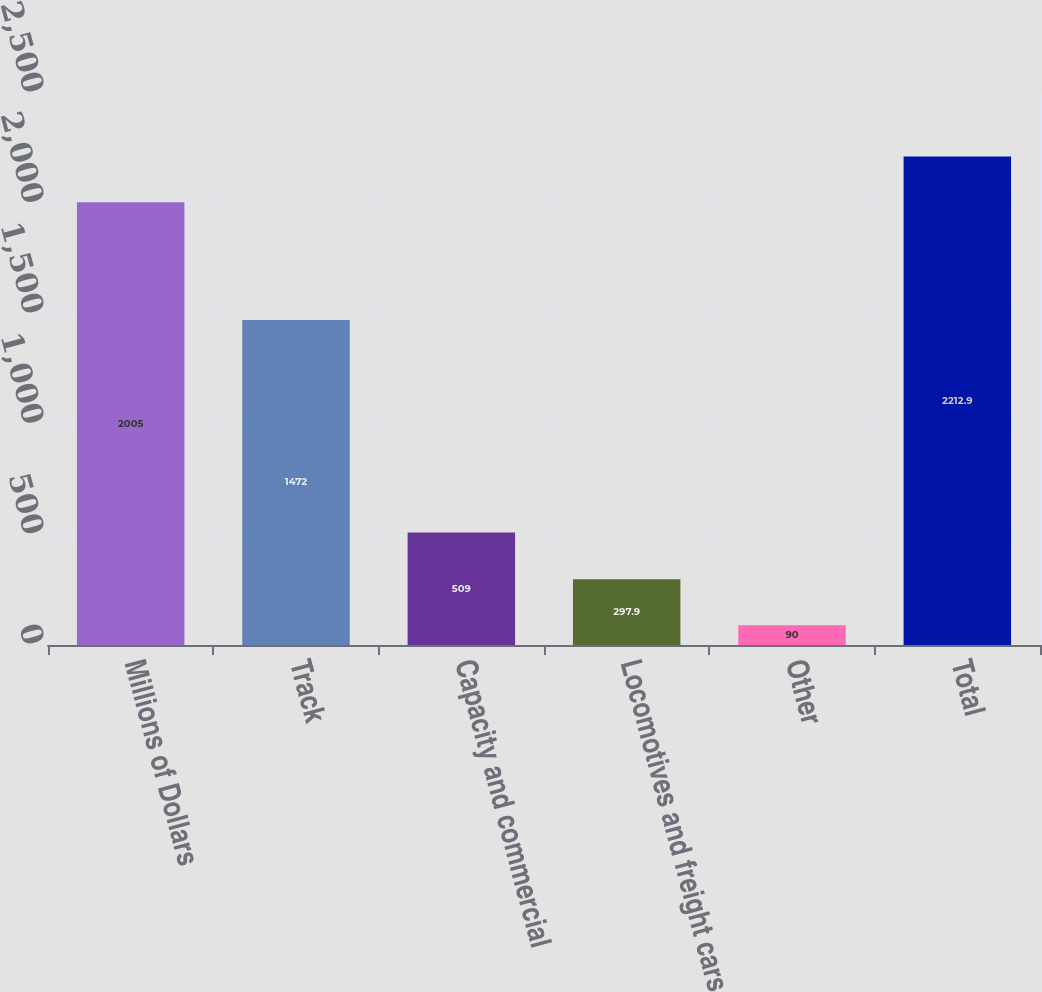Convert chart to OTSL. <chart><loc_0><loc_0><loc_500><loc_500><bar_chart><fcel>Millions of Dollars<fcel>Track<fcel>Capacity and commercial<fcel>Locomotives and freight cars<fcel>Other<fcel>Total<nl><fcel>2005<fcel>1472<fcel>509<fcel>297.9<fcel>90<fcel>2212.9<nl></chart> 